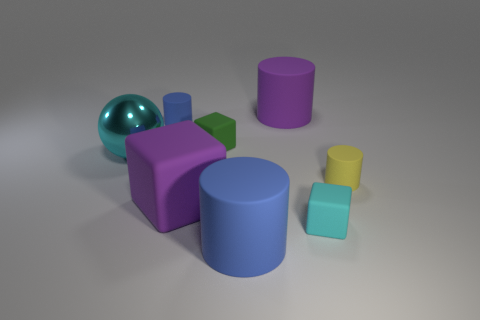There is a blue rubber cylinder behind the small cyan rubber thing; is there a big rubber object behind it?
Offer a terse response. Yes. How many things are blue cylinders that are left of the small green object or big purple rubber cylinders?
Give a very brief answer. 2. What number of green matte objects are there?
Your answer should be very brief. 1. There is a tiny yellow thing that is the same material as the big blue cylinder; what is its shape?
Provide a short and direct response. Cylinder. How big is the cylinder that is left of the blue rubber object in front of the tiny cyan rubber thing?
Ensure brevity in your answer.  Small. What number of objects are either big rubber cylinders that are behind the green cube or tiny things that are behind the big purple matte block?
Your response must be concise. 4. Are there fewer purple things than big rubber things?
Keep it short and to the point. Yes. What number of things are green rubber spheres or tiny rubber things?
Your answer should be very brief. 4. Is the small green rubber thing the same shape as the tiny cyan object?
Make the answer very short. Yes. Is there any other thing that has the same material as the big ball?
Give a very brief answer. No. 